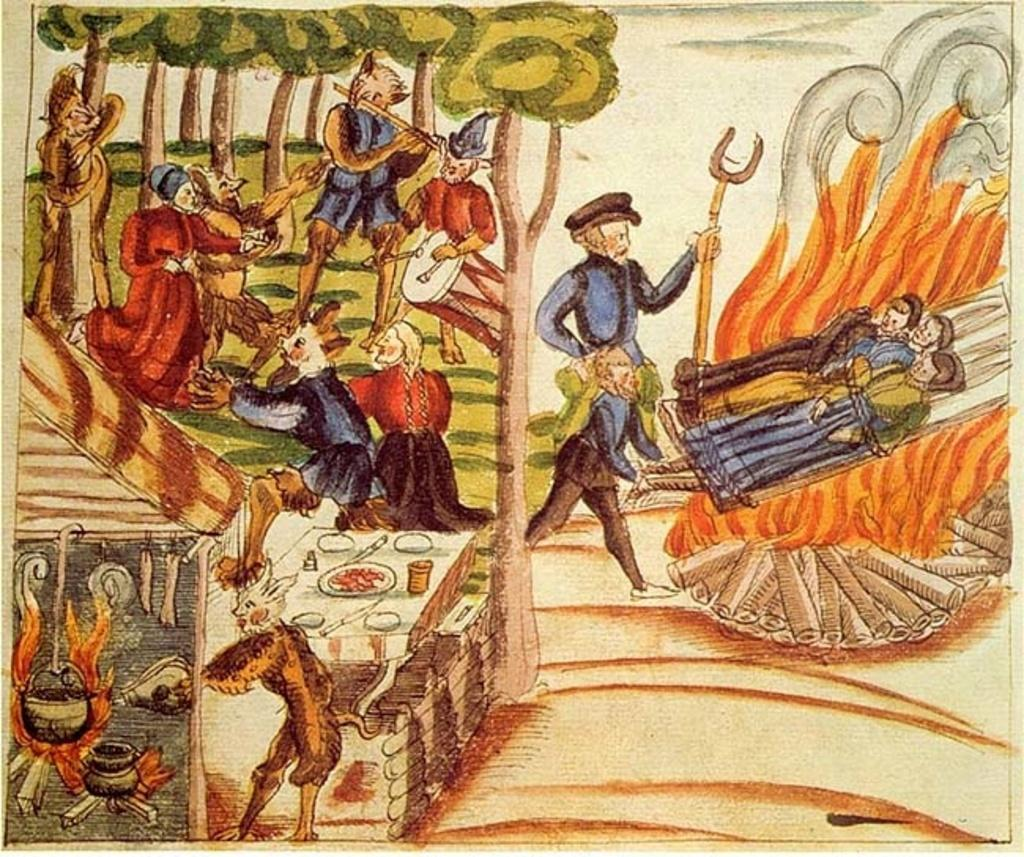What type of artwork is depicted in the image? The image is a painting. What can be seen in the painting? There are people, a fire, logs, trees, and animals in the painting. Can you describe the setting of the painting? The painting features a fire and logs, which suggests a campfire or outdoor setting. The presence of trees also supports this idea. What type of bubble can be seen floating near the fire in the painting? There is no bubble present in the painting; it features a fire, logs, trees, and animals. 